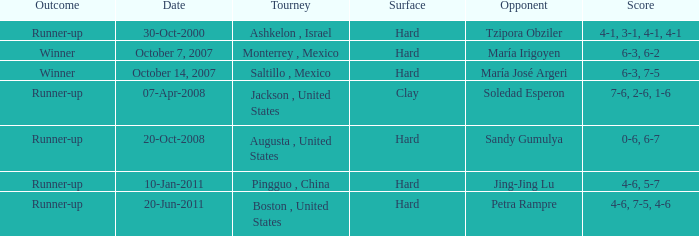Which tournament was held on October 14, 2007? Saltillo , Mexico. 